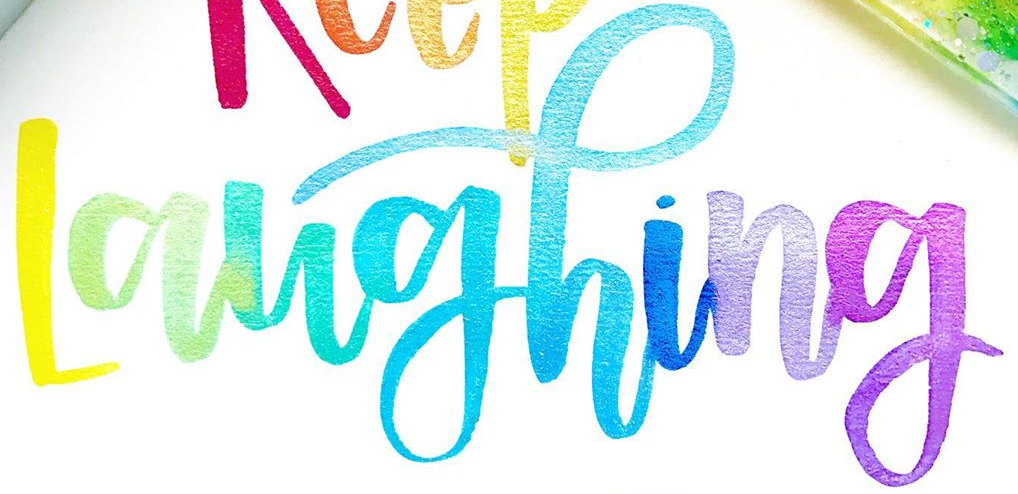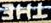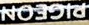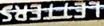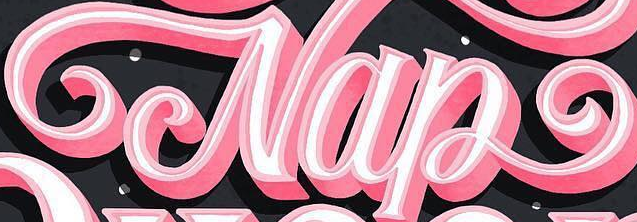Identify the words shown in these images in order, separated by a semicolon. Laughing; THE; PIGEON; LETTERS; Nap 